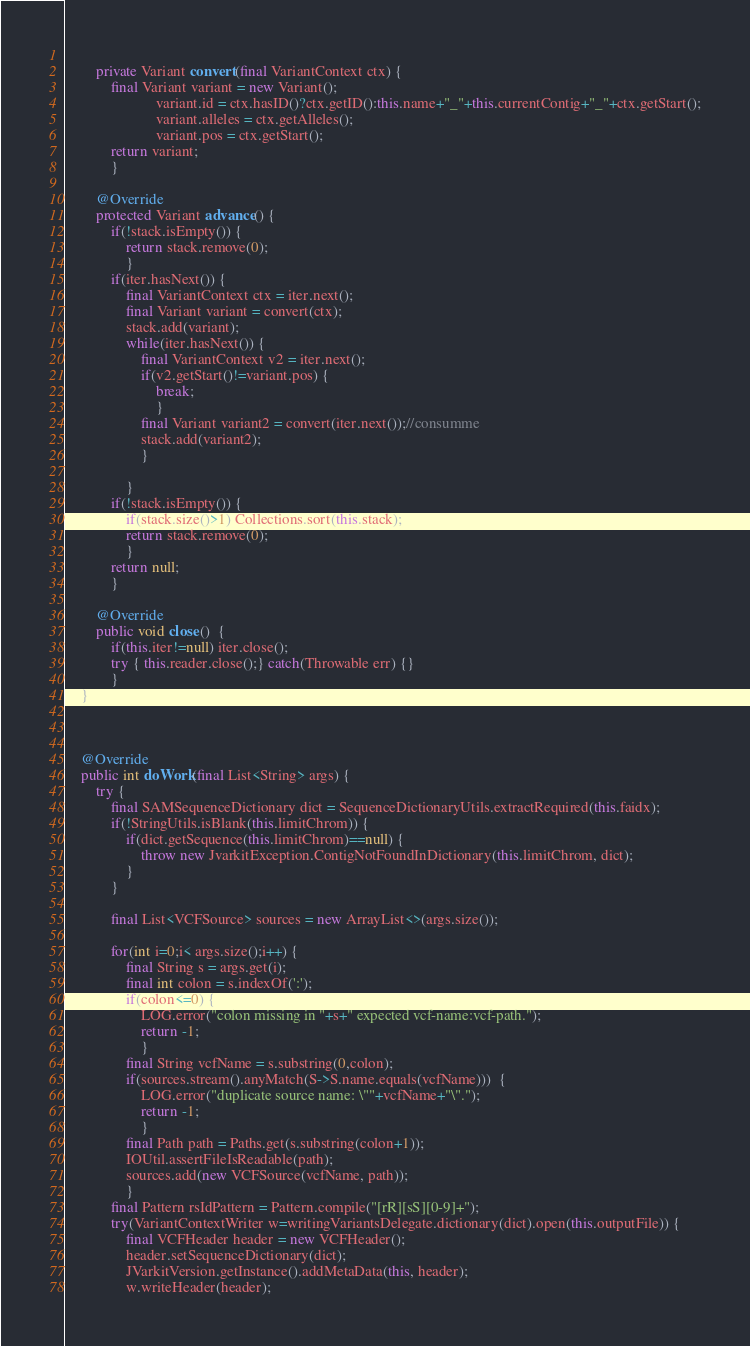Convert code to text. <code><loc_0><loc_0><loc_500><loc_500><_Java_>		
		private Variant convert(final VariantContext ctx) {
	 		final Variant variant = new Variant();
                        variant.id = ctx.hasID()?ctx.getID():this.name+"_"+this.currentContig+"_"+ctx.getStart();
                        variant.alleles = ctx.getAlleles();
                        variant.pos = ctx.getStart();
			return variant;
			}

		@Override
		protected Variant advance() {
			if(!stack.isEmpty()) {
				return stack.remove(0);
				}
			if(iter.hasNext()) {
				final VariantContext ctx = iter.next();
				final Variant variant = convert(ctx);
				stack.add(variant);
				while(iter.hasNext()) {
					final VariantContext v2 = iter.next();
					if(v2.getStart()!=variant.pos) {
						break;
						}
					final Variant variant2 = convert(iter.next());//consumme
					stack.add(variant2);
					}
					
				}
			if(!stack.isEmpty()) {
				if(stack.size()>1) Collections.sort(this.stack);
				return stack.remove(0);
				}
			return null;
			}
		
		@Override
		public void close()  {
			if(this.iter!=null) iter.close();
			try { this.reader.close();} catch(Throwable err) {} 
			}
	}


	
	@Override
	public int doWork(final List<String> args) {
		try {
			final SAMSequenceDictionary dict = SequenceDictionaryUtils.extractRequired(this.faidx);
			if(!StringUtils.isBlank(this.limitChrom)) {
				if(dict.getSequence(this.limitChrom)==null) {
					throw new JvarkitException.ContigNotFoundInDictionary(this.limitChrom, dict);
				}
			}
			
			final List<VCFSource> sources = new ArrayList<>(args.size());
			
			for(int i=0;i< args.size();i++) {
				final String s = args.get(i);
				final int colon = s.indexOf(':');
				if(colon<=0) {
					LOG.error("colon missing in "+s+" expected vcf-name:vcf-path.");
					return -1;
					}
				final String vcfName = s.substring(0,colon);
				if(sources.stream().anyMatch(S->S.name.equals(vcfName)))  {
					LOG.error("duplicate source name: \""+vcfName+"\".");
					return -1;
					}
				final Path path = Paths.get(s.substring(colon+1));
				IOUtil.assertFileIsReadable(path);
				sources.add(new VCFSource(vcfName, path));
				}
			final Pattern rsIdPattern = Pattern.compile("[rR][sS][0-9]+");
			try(VariantContextWriter w=writingVariantsDelegate.dictionary(dict).open(this.outputFile)) {
				final VCFHeader header = new VCFHeader();
				header.setSequenceDictionary(dict);
				JVarkitVersion.getInstance().addMetaData(this, header);
				w.writeHeader(header);</code> 